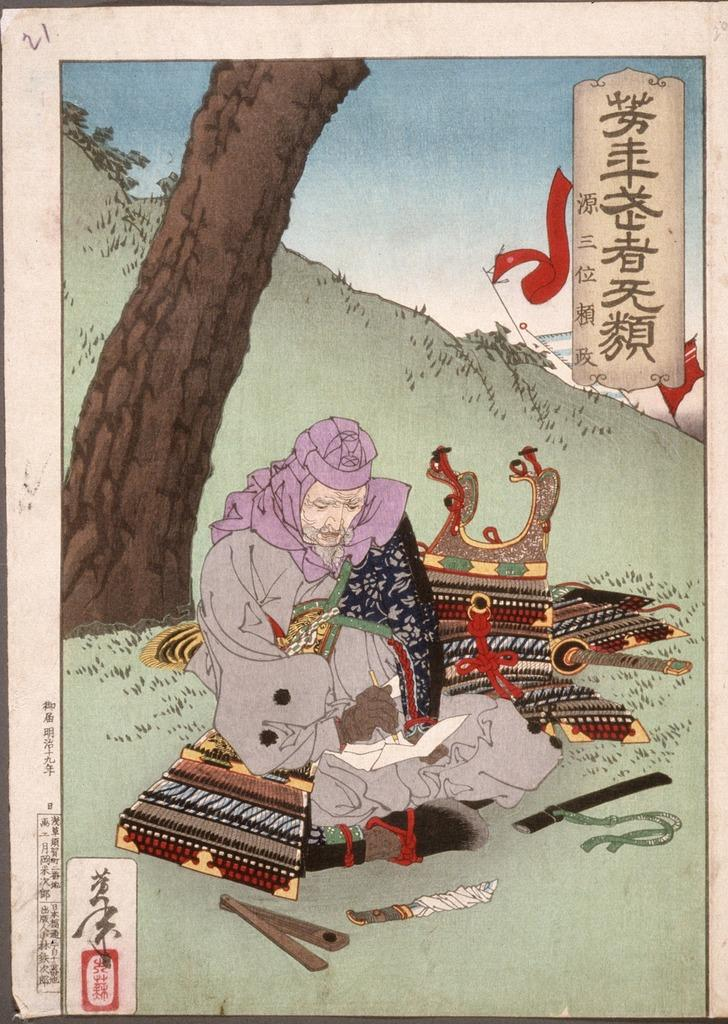What is the main subject of the art piece in the image? The art piece depicts a woman. Are there any objects present in the art piece? Yes, a knife, the trunk of a tree, and other objects are visible in the art piece. What type of landscape is depicted in the art piece? There is a hill depicted in the art piece. What part of the natural environment is visible in the art piece? The sky is visible in the art piece. Is there any text present in the art piece? Yes, there is text present in the art piece. How many tickets can be seen in the art piece? There are no tickets present in the art piece; it depicts a woman, objects, and text. 